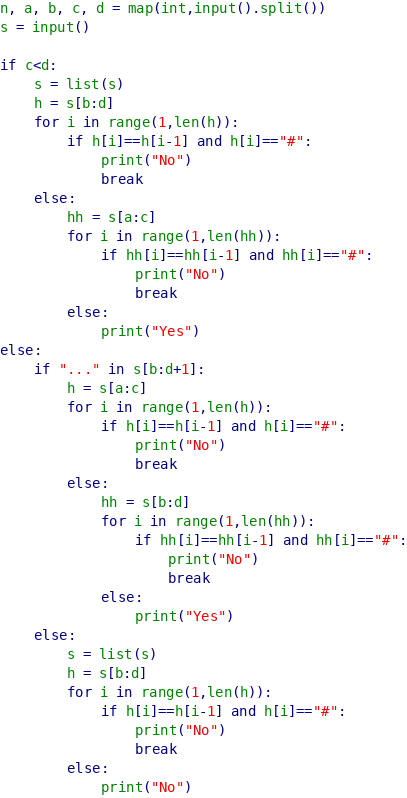Convert code to text. <code><loc_0><loc_0><loc_500><loc_500><_Python_>n, a, b, c, d = map(int,input().split())
s = input()

if c<d:
    s = list(s)
    h = s[b:d]
    for i in range(1,len(h)):
        if h[i]==h[i-1] and h[i]=="#":
            print("No")
            break
    else:
        hh = s[a:c]
        for i in range(1,len(hh)):
            if hh[i]==hh[i-1] and hh[i]=="#":
                print("No")
                break
        else:
            print("Yes")
else:
    if "..." in s[b:d+1]:
        h = s[a:c]
        for i in range(1,len(h)):
            if h[i]==h[i-1] and h[i]=="#":
                print("No")
                break
        else:
            hh = s[b:d]
            for i in range(1,len(hh)):
                if hh[i]==hh[i-1] and hh[i]=="#":
                    print("No")
                    break
            else:
                print("Yes")
    else:
        s = list(s)
        h = s[b:d]
        for i in range(1,len(h)):
            if h[i]==h[i-1] and h[i]=="#":
                print("No")
                break
        else:
            print("No")



</code> 